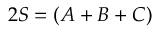<formula> <loc_0><loc_0><loc_500><loc_500>2 S = ( A + B + C )</formula> 